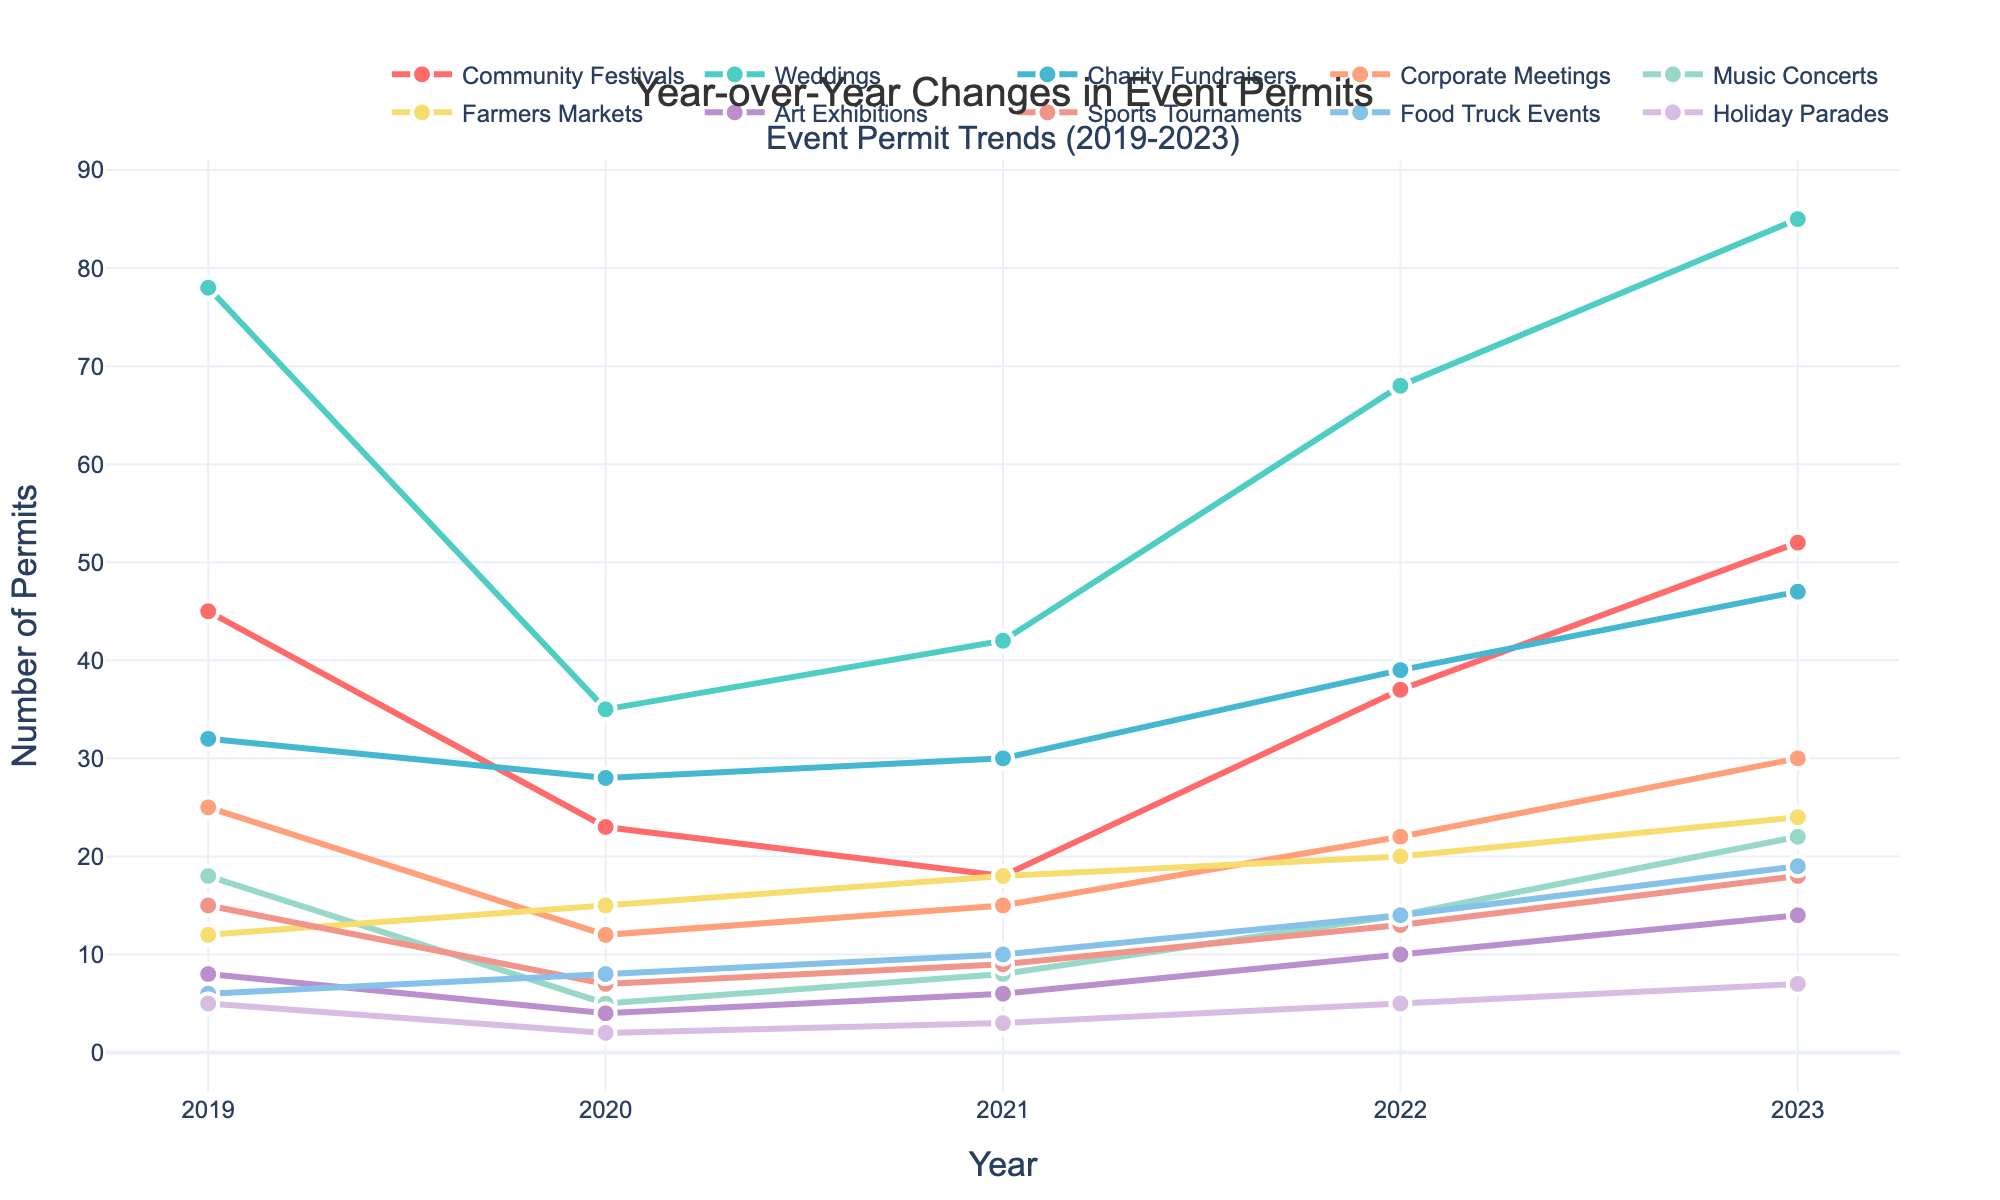what's the trend of event permits for Community Festivals from 2019 to 2023? Looking at the "Community Festivals" line, it starts at 45 in 2019, drops to 23 in 2020, decreases further to 18 in 2021, then increases to 37 in 2022, and finally rises to 52 in 2023. Thus, the trend shows a sharp decline until 2021 and then a steady increase through 2023.
Answer: Decline until 2021, then increase which event type saw the largest increase in permits from 2021 to 2023? By comparing the difference in permits between 2021 and 2023 for each event type, "Weddings" has the largest increase (85 in 2023 minus 42 in 2021 equals 43).
Answer: Weddings How did the number of permits for Corporate Meetings change from 2020 to 2022? Observing the "Corporate Meetings" line, the permits were 12 in 2020, rose to 15 in 2021, and then further increased to 22 in 2022. This indicates a year-by-year increase during this period.
Answer: Increased Which event type has consistently increased in the number of permits from 2019 to 2023? "Farmers Markets" is the event type where the number of permits increases consistently each year—12 in 2019, 15 in 2020, 18 in 2021, 20 in 2022, and 24 in 2023.
Answer: Farmers Markets What is the difference in the number of permits issued for Music Concerts between the years 2019 and 2020? In 2019, Music Concerts had 18 permits issued, and in 2020, there were only 5 permits issued, so the difference is 18 minus 5, which equals 13.
Answer: 13 Which event type had the lowest number of permits in 2023? By examining the endpoint of each line in 2023, "Holiday Parades" had the lowest number of permits with only 7.
Answer: Holiday Parades How many more permits were issued for Weddings compared to Charity Fundraisers in 2023? In 2023, Weddings had 85 permits issued and Charity Fundraisers had 47. The difference is 85 minus 47, which equals 38.
Answer: 38 By how much did the number of permits for Art Exhibitions change from 2019 to 2022? The permits for Art Exhibitions were 8 in 2019 and 10 in 2022. Therefore, the change is 10 minus 8, which equals 2.
Answer: 2 Which event type experienced the most significant drop in permits from 2019 to 2020? By calculating the differences between the years, "Music Concerts" saw a drop from 18 permits in 2019 to 5 permits in 2020, a decrease of 13. This is the most significant drop.
Answer: Music Concerts From 2021 to 2022, which event types showed an increase in permits? By examining the trend from 2021 to 2022 for each event type, "Community Festivals," "Weddings," "Charity Fundraisers," "Corporate Meetings," "Music Concerts," "Farmers Markets," "Art Exhibitions," "Sports Tournaments," and "Food Truck Events" all show an increase in the number of permits. "Holiday Parades" stayed the same. This means that all but one showed an increase.
Answer: All but Holiday Parades 